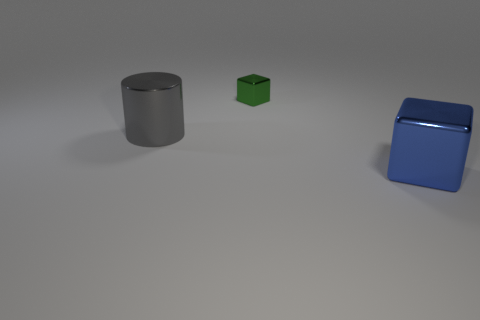How many green metal things are to the left of the block in front of the metallic cylinder?
Your response must be concise. 1. Is the number of large things that are in front of the gray metal object less than the number of big gray shiny cylinders?
Offer a very short reply. No. There is a large gray metallic thing in front of the object behind the cylinder; is there a large blue thing that is on the right side of it?
Offer a terse response. Yes. Is the material of the large gray cylinder the same as the thing to the right of the small green metallic block?
Offer a very short reply. Yes. The cube that is on the left side of the large thing that is right of the tiny green thing is what color?
Your answer should be compact. Green. What is the size of the metal thing behind the big thing that is left of the big thing in front of the gray cylinder?
Your answer should be compact. Small. Does the green metal thing have the same shape as the shiny thing that is left of the tiny metallic cube?
Provide a short and direct response. No. How many other objects are the same size as the green metallic thing?
Provide a succinct answer. 0. There is a cube in front of the gray thing; how big is it?
Provide a succinct answer. Large. What number of gray objects have the same material as the green object?
Give a very brief answer. 1. 